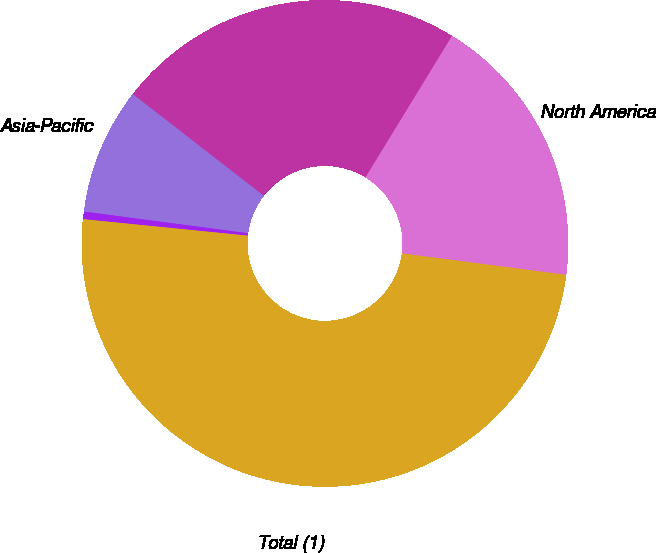Convert chart. <chart><loc_0><loc_0><loc_500><loc_500><pie_chart><fcel>North America<fcel>Europe and Africa<fcel>Asia-Pacific<fcel>South America<fcel>Total (1)<nl><fcel>18.33%<fcel>23.23%<fcel>8.42%<fcel>0.5%<fcel>49.53%<nl></chart> 